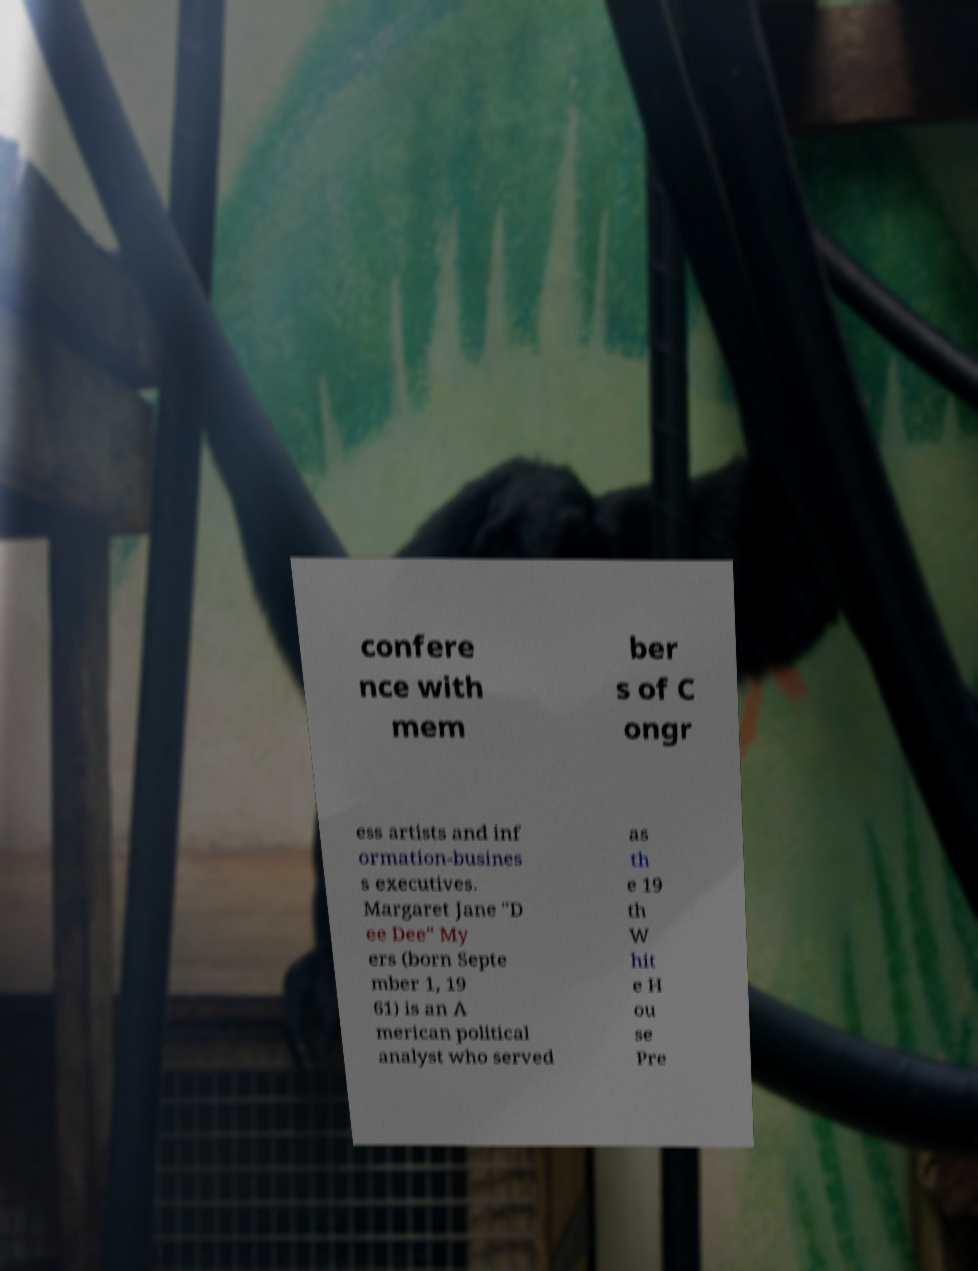Please identify and transcribe the text found in this image. confere nce with mem ber s of C ongr ess artists and inf ormation-busines s executives. Margaret Jane "D ee Dee" My ers (born Septe mber 1, 19 61) is an A merican political analyst who served as th e 19 th W hit e H ou se Pre 